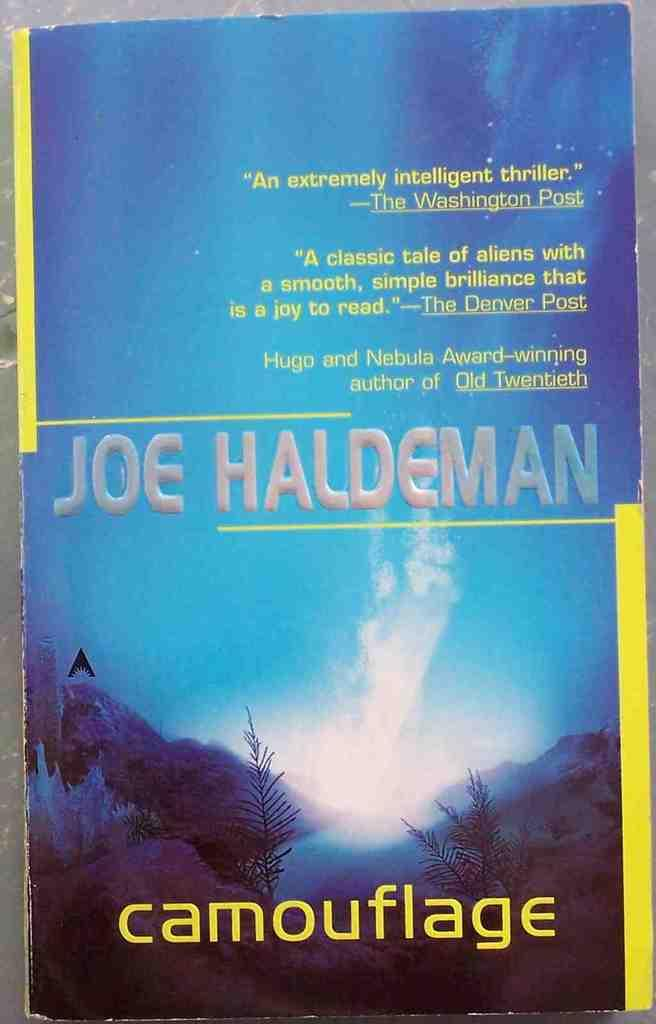<image>
Create a compact narrative representing the image presented. A book by Joe Haldeman titled Camouflage, in the color blue 